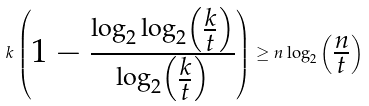<formula> <loc_0><loc_0><loc_500><loc_500>k \begin{pmatrix} 1 - { \frac { \log _ { 2 } \log _ { 2 } \begin{pmatrix} { \frac { k } { t } } \end{pmatrix} } { \log _ { 2 } \begin{pmatrix} { \frac { k } { t } } \end{pmatrix} } } \end{pmatrix} \geq n \log _ { 2 } \begin{pmatrix} { \frac { n } { t } } \end{pmatrix}</formula> 